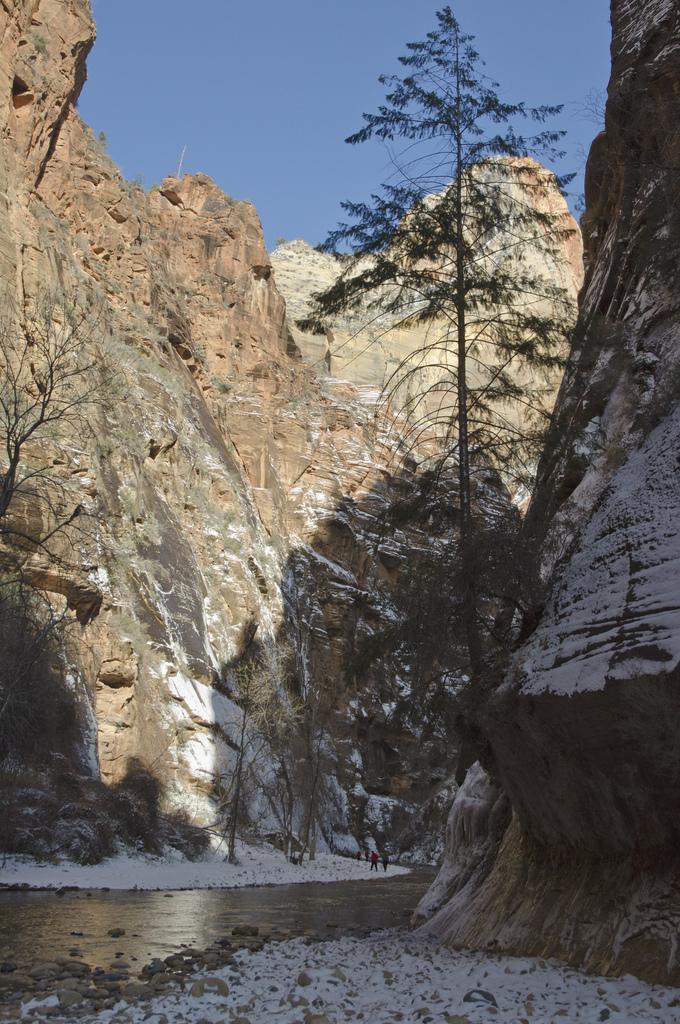In one or two sentences, can you explain what this image depicts? In this picture I can see water, two persons, snow, stones, trees, hills, and in the background there is sky. 